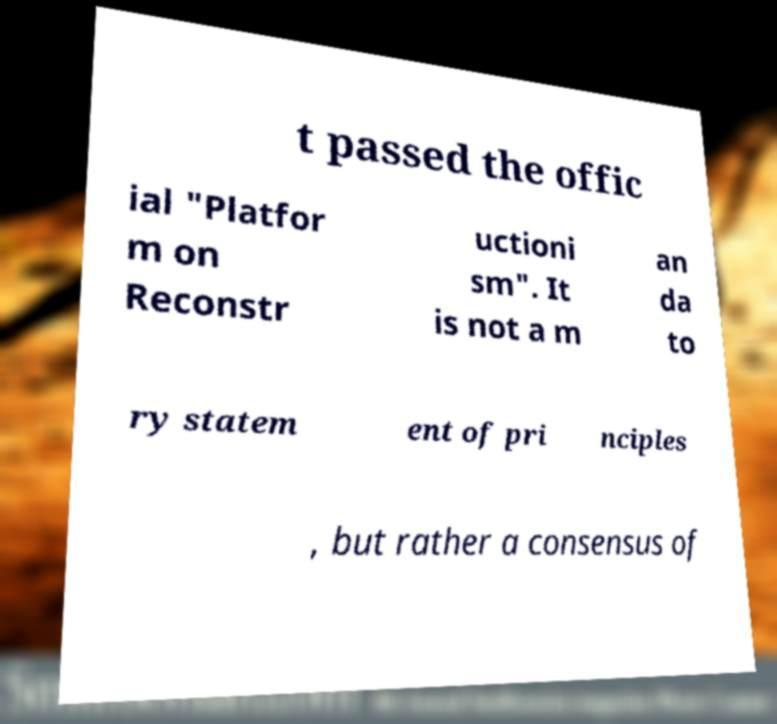There's text embedded in this image that I need extracted. Can you transcribe it verbatim? t passed the offic ial "Platfor m on Reconstr uctioni sm". It is not a m an da to ry statem ent of pri nciples , but rather a consensus of 